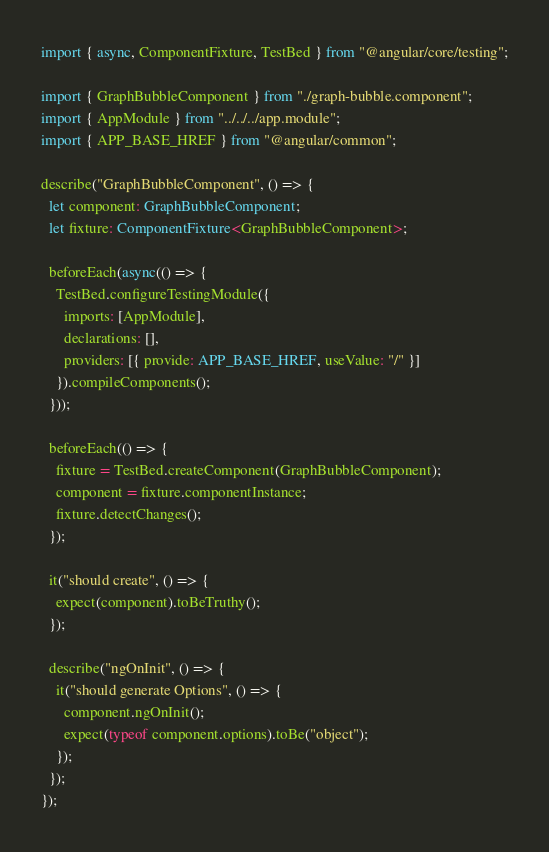Convert code to text. <code><loc_0><loc_0><loc_500><loc_500><_TypeScript_>import { async, ComponentFixture, TestBed } from "@angular/core/testing";

import { GraphBubbleComponent } from "./graph-bubble.component";
import { AppModule } from "../../../app.module";
import { APP_BASE_HREF } from "@angular/common";

describe("GraphBubbleComponent", () => {
  let component: GraphBubbleComponent;
  let fixture: ComponentFixture<GraphBubbleComponent>;

  beforeEach(async(() => {
    TestBed.configureTestingModule({
      imports: [AppModule],
      declarations: [],
      providers: [{ provide: APP_BASE_HREF, useValue: "/" }]
    }).compileComponents();
  }));

  beforeEach(() => {
    fixture = TestBed.createComponent(GraphBubbleComponent);
    component = fixture.componentInstance;
    fixture.detectChanges();
  });

  it("should create", () => {
    expect(component).toBeTruthy();
  });

  describe("ngOnInit", () => {
    it("should generate Options", () => {
      component.ngOnInit();
      expect(typeof component.options).toBe("object");
    });
  });
});
</code> 